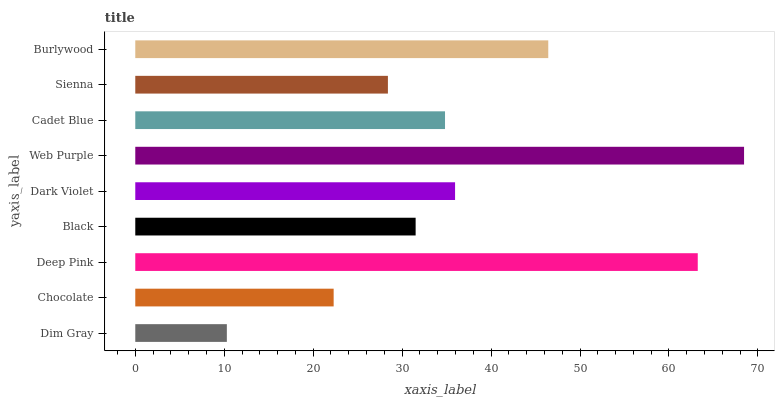Is Dim Gray the minimum?
Answer yes or no. Yes. Is Web Purple the maximum?
Answer yes or no. Yes. Is Chocolate the minimum?
Answer yes or no. No. Is Chocolate the maximum?
Answer yes or no. No. Is Chocolate greater than Dim Gray?
Answer yes or no. Yes. Is Dim Gray less than Chocolate?
Answer yes or no. Yes. Is Dim Gray greater than Chocolate?
Answer yes or no. No. Is Chocolate less than Dim Gray?
Answer yes or no. No. Is Cadet Blue the high median?
Answer yes or no. Yes. Is Cadet Blue the low median?
Answer yes or no. Yes. Is Dim Gray the high median?
Answer yes or no. No. Is Burlywood the low median?
Answer yes or no. No. 